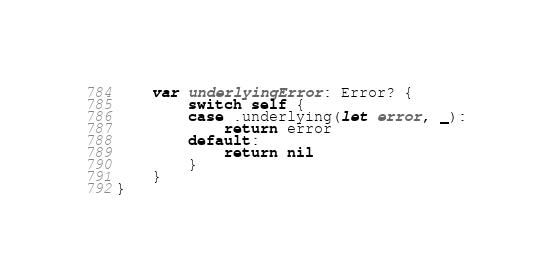<code> <loc_0><loc_0><loc_500><loc_500><_Swift_>
    var underlyingError: Error? {
        switch self {
        case .underlying(let error, _):
            return error
        default:
            return nil
        }
    }
}
</code> 